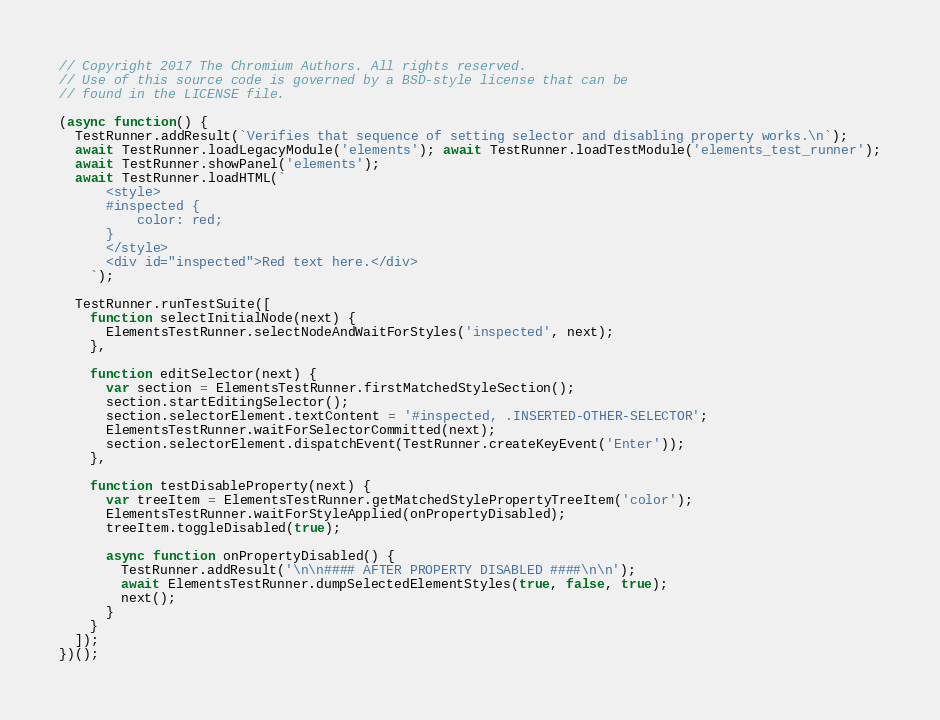Convert code to text. <code><loc_0><loc_0><loc_500><loc_500><_JavaScript_>// Copyright 2017 The Chromium Authors. All rights reserved.
// Use of this source code is governed by a BSD-style license that can be
// found in the LICENSE file.

(async function() {
  TestRunner.addResult(`Verifies that sequence of setting selector and disabling property works.\n`);
  await TestRunner.loadLegacyModule('elements'); await TestRunner.loadTestModule('elements_test_runner');
  await TestRunner.showPanel('elements');
  await TestRunner.loadHTML(`
      <style>
      #inspected {
          color: red;
      }
      </style>
      <div id="inspected">Red text here.</div>
    `);

  TestRunner.runTestSuite([
    function selectInitialNode(next) {
      ElementsTestRunner.selectNodeAndWaitForStyles('inspected', next);
    },

    function editSelector(next) {
      var section = ElementsTestRunner.firstMatchedStyleSection();
      section.startEditingSelector();
      section.selectorElement.textContent = '#inspected, .INSERTED-OTHER-SELECTOR';
      ElementsTestRunner.waitForSelectorCommitted(next);
      section.selectorElement.dispatchEvent(TestRunner.createKeyEvent('Enter'));
    },

    function testDisableProperty(next) {
      var treeItem = ElementsTestRunner.getMatchedStylePropertyTreeItem('color');
      ElementsTestRunner.waitForStyleApplied(onPropertyDisabled);
      treeItem.toggleDisabled(true);

      async function onPropertyDisabled() {
        TestRunner.addResult('\n\n#### AFTER PROPERTY DISABLED ####\n\n');
        await ElementsTestRunner.dumpSelectedElementStyles(true, false, true);
        next();
      }
    }
  ]);
})();
</code> 